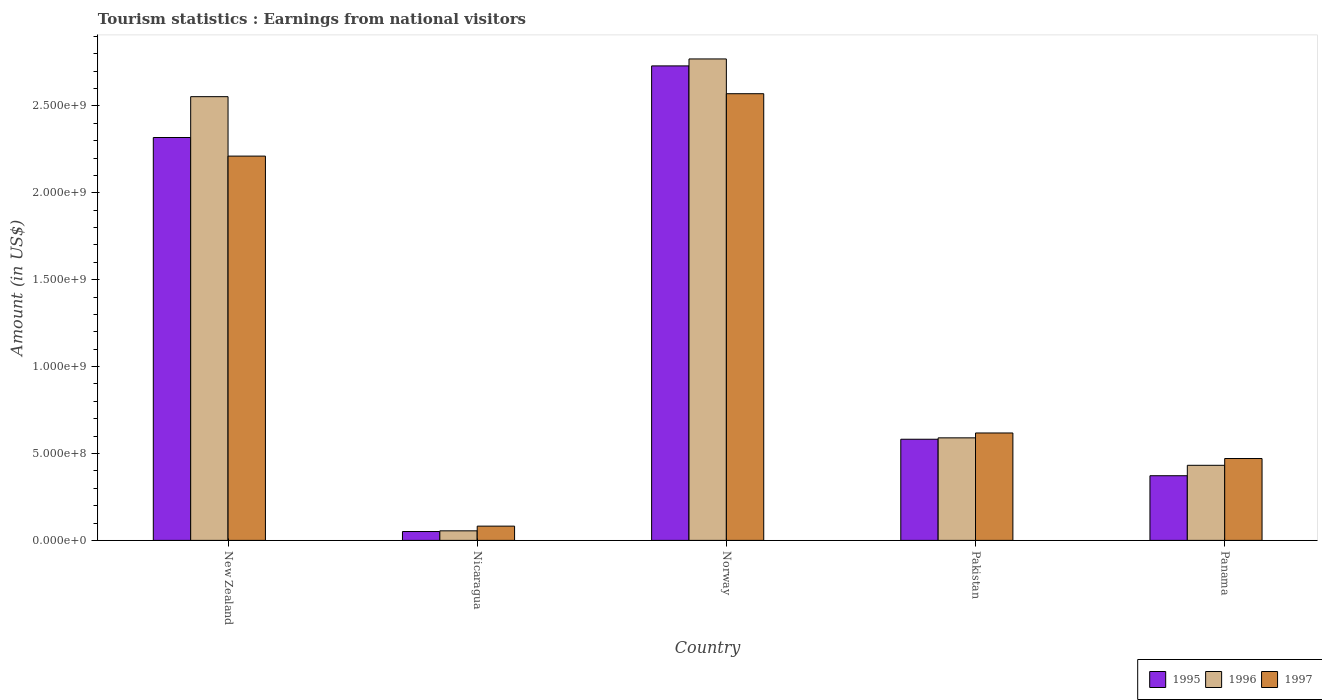How many different coloured bars are there?
Provide a short and direct response. 3. How many groups of bars are there?
Provide a short and direct response. 5. How many bars are there on the 4th tick from the right?
Your response must be concise. 3. What is the label of the 2nd group of bars from the left?
Offer a terse response. Nicaragua. In how many cases, is the number of bars for a given country not equal to the number of legend labels?
Make the answer very short. 0. What is the earnings from national visitors in 1995 in New Zealand?
Offer a terse response. 2.32e+09. Across all countries, what is the maximum earnings from national visitors in 1997?
Your answer should be compact. 2.57e+09. Across all countries, what is the minimum earnings from national visitors in 1997?
Offer a terse response. 8.20e+07. In which country was the earnings from national visitors in 1995 minimum?
Keep it short and to the point. Nicaragua. What is the total earnings from national visitors in 1996 in the graph?
Your response must be concise. 6.40e+09. What is the difference between the earnings from national visitors in 1996 in Norway and that in Pakistan?
Provide a succinct answer. 2.18e+09. What is the difference between the earnings from national visitors in 1996 in Norway and the earnings from national visitors in 1995 in Panama?
Keep it short and to the point. 2.40e+09. What is the average earnings from national visitors in 1997 per country?
Give a very brief answer. 1.19e+09. What is the difference between the earnings from national visitors of/in 1997 and earnings from national visitors of/in 1995 in New Zealand?
Give a very brief answer. -1.07e+08. In how many countries, is the earnings from national visitors in 1997 greater than 1600000000 US$?
Your answer should be very brief. 2. What is the ratio of the earnings from national visitors in 1997 in Pakistan to that in Panama?
Ensure brevity in your answer.  1.31. Is the earnings from national visitors in 1995 in Nicaragua less than that in Norway?
Give a very brief answer. Yes. Is the difference between the earnings from national visitors in 1997 in New Zealand and Pakistan greater than the difference between the earnings from national visitors in 1995 in New Zealand and Pakistan?
Offer a terse response. No. What is the difference between the highest and the second highest earnings from national visitors in 1995?
Make the answer very short. 2.15e+09. What is the difference between the highest and the lowest earnings from national visitors in 1995?
Make the answer very short. 2.68e+09. What does the 3rd bar from the left in New Zealand represents?
Give a very brief answer. 1997. What does the 1st bar from the right in Pakistan represents?
Provide a succinct answer. 1997. How many countries are there in the graph?
Make the answer very short. 5. What is the difference between two consecutive major ticks on the Y-axis?
Provide a succinct answer. 5.00e+08. Are the values on the major ticks of Y-axis written in scientific E-notation?
Make the answer very short. Yes. Does the graph contain any zero values?
Make the answer very short. No. Where does the legend appear in the graph?
Give a very brief answer. Bottom right. How are the legend labels stacked?
Your response must be concise. Horizontal. What is the title of the graph?
Give a very brief answer. Tourism statistics : Earnings from national visitors. What is the label or title of the Y-axis?
Your answer should be compact. Amount (in US$). What is the Amount (in US$) of 1995 in New Zealand?
Provide a short and direct response. 2.32e+09. What is the Amount (in US$) of 1996 in New Zealand?
Make the answer very short. 2.55e+09. What is the Amount (in US$) in 1997 in New Zealand?
Your response must be concise. 2.21e+09. What is the Amount (in US$) of 1995 in Nicaragua?
Offer a terse response. 5.10e+07. What is the Amount (in US$) of 1996 in Nicaragua?
Your answer should be compact. 5.50e+07. What is the Amount (in US$) in 1997 in Nicaragua?
Your answer should be very brief. 8.20e+07. What is the Amount (in US$) of 1995 in Norway?
Your answer should be compact. 2.73e+09. What is the Amount (in US$) of 1996 in Norway?
Keep it short and to the point. 2.77e+09. What is the Amount (in US$) of 1997 in Norway?
Offer a terse response. 2.57e+09. What is the Amount (in US$) of 1995 in Pakistan?
Your answer should be very brief. 5.82e+08. What is the Amount (in US$) of 1996 in Pakistan?
Ensure brevity in your answer.  5.90e+08. What is the Amount (in US$) in 1997 in Pakistan?
Provide a short and direct response. 6.18e+08. What is the Amount (in US$) in 1995 in Panama?
Offer a terse response. 3.72e+08. What is the Amount (in US$) in 1996 in Panama?
Your answer should be compact. 4.32e+08. What is the Amount (in US$) in 1997 in Panama?
Keep it short and to the point. 4.71e+08. Across all countries, what is the maximum Amount (in US$) in 1995?
Make the answer very short. 2.73e+09. Across all countries, what is the maximum Amount (in US$) in 1996?
Offer a very short reply. 2.77e+09. Across all countries, what is the maximum Amount (in US$) of 1997?
Make the answer very short. 2.57e+09. Across all countries, what is the minimum Amount (in US$) of 1995?
Provide a succinct answer. 5.10e+07. Across all countries, what is the minimum Amount (in US$) in 1996?
Make the answer very short. 5.50e+07. Across all countries, what is the minimum Amount (in US$) in 1997?
Keep it short and to the point. 8.20e+07. What is the total Amount (in US$) in 1995 in the graph?
Your response must be concise. 6.05e+09. What is the total Amount (in US$) of 1996 in the graph?
Give a very brief answer. 6.40e+09. What is the total Amount (in US$) in 1997 in the graph?
Provide a succinct answer. 5.95e+09. What is the difference between the Amount (in US$) in 1995 in New Zealand and that in Nicaragua?
Offer a very short reply. 2.27e+09. What is the difference between the Amount (in US$) of 1996 in New Zealand and that in Nicaragua?
Keep it short and to the point. 2.50e+09. What is the difference between the Amount (in US$) of 1997 in New Zealand and that in Nicaragua?
Ensure brevity in your answer.  2.13e+09. What is the difference between the Amount (in US$) in 1995 in New Zealand and that in Norway?
Keep it short and to the point. -4.12e+08. What is the difference between the Amount (in US$) in 1996 in New Zealand and that in Norway?
Ensure brevity in your answer.  -2.17e+08. What is the difference between the Amount (in US$) of 1997 in New Zealand and that in Norway?
Make the answer very short. -3.59e+08. What is the difference between the Amount (in US$) of 1995 in New Zealand and that in Pakistan?
Your answer should be compact. 1.74e+09. What is the difference between the Amount (in US$) in 1996 in New Zealand and that in Pakistan?
Your response must be concise. 1.96e+09. What is the difference between the Amount (in US$) in 1997 in New Zealand and that in Pakistan?
Your response must be concise. 1.59e+09. What is the difference between the Amount (in US$) of 1995 in New Zealand and that in Panama?
Ensure brevity in your answer.  1.95e+09. What is the difference between the Amount (in US$) of 1996 in New Zealand and that in Panama?
Ensure brevity in your answer.  2.12e+09. What is the difference between the Amount (in US$) in 1997 in New Zealand and that in Panama?
Make the answer very short. 1.74e+09. What is the difference between the Amount (in US$) in 1995 in Nicaragua and that in Norway?
Give a very brief answer. -2.68e+09. What is the difference between the Amount (in US$) in 1996 in Nicaragua and that in Norway?
Your answer should be very brief. -2.72e+09. What is the difference between the Amount (in US$) of 1997 in Nicaragua and that in Norway?
Give a very brief answer. -2.49e+09. What is the difference between the Amount (in US$) in 1995 in Nicaragua and that in Pakistan?
Your response must be concise. -5.31e+08. What is the difference between the Amount (in US$) in 1996 in Nicaragua and that in Pakistan?
Your answer should be very brief. -5.35e+08. What is the difference between the Amount (in US$) of 1997 in Nicaragua and that in Pakistan?
Your answer should be very brief. -5.36e+08. What is the difference between the Amount (in US$) of 1995 in Nicaragua and that in Panama?
Your answer should be compact. -3.21e+08. What is the difference between the Amount (in US$) in 1996 in Nicaragua and that in Panama?
Make the answer very short. -3.77e+08. What is the difference between the Amount (in US$) in 1997 in Nicaragua and that in Panama?
Make the answer very short. -3.89e+08. What is the difference between the Amount (in US$) of 1995 in Norway and that in Pakistan?
Give a very brief answer. 2.15e+09. What is the difference between the Amount (in US$) of 1996 in Norway and that in Pakistan?
Your answer should be compact. 2.18e+09. What is the difference between the Amount (in US$) of 1997 in Norway and that in Pakistan?
Offer a terse response. 1.95e+09. What is the difference between the Amount (in US$) in 1995 in Norway and that in Panama?
Keep it short and to the point. 2.36e+09. What is the difference between the Amount (in US$) in 1996 in Norway and that in Panama?
Offer a very short reply. 2.34e+09. What is the difference between the Amount (in US$) in 1997 in Norway and that in Panama?
Your response must be concise. 2.10e+09. What is the difference between the Amount (in US$) of 1995 in Pakistan and that in Panama?
Offer a very short reply. 2.10e+08. What is the difference between the Amount (in US$) in 1996 in Pakistan and that in Panama?
Ensure brevity in your answer.  1.58e+08. What is the difference between the Amount (in US$) of 1997 in Pakistan and that in Panama?
Your response must be concise. 1.47e+08. What is the difference between the Amount (in US$) in 1995 in New Zealand and the Amount (in US$) in 1996 in Nicaragua?
Give a very brief answer. 2.26e+09. What is the difference between the Amount (in US$) of 1995 in New Zealand and the Amount (in US$) of 1997 in Nicaragua?
Offer a terse response. 2.24e+09. What is the difference between the Amount (in US$) of 1996 in New Zealand and the Amount (in US$) of 1997 in Nicaragua?
Your response must be concise. 2.47e+09. What is the difference between the Amount (in US$) of 1995 in New Zealand and the Amount (in US$) of 1996 in Norway?
Provide a succinct answer. -4.52e+08. What is the difference between the Amount (in US$) in 1995 in New Zealand and the Amount (in US$) in 1997 in Norway?
Offer a terse response. -2.52e+08. What is the difference between the Amount (in US$) of 1996 in New Zealand and the Amount (in US$) of 1997 in Norway?
Keep it short and to the point. -1.70e+07. What is the difference between the Amount (in US$) in 1995 in New Zealand and the Amount (in US$) in 1996 in Pakistan?
Provide a succinct answer. 1.73e+09. What is the difference between the Amount (in US$) in 1995 in New Zealand and the Amount (in US$) in 1997 in Pakistan?
Provide a succinct answer. 1.70e+09. What is the difference between the Amount (in US$) of 1996 in New Zealand and the Amount (in US$) of 1997 in Pakistan?
Keep it short and to the point. 1.94e+09. What is the difference between the Amount (in US$) of 1995 in New Zealand and the Amount (in US$) of 1996 in Panama?
Your answer should be compact. 1.89e+09. What is the difference between the Amount (in US$) of 1995 in New Zealand and the Amount (in US$) of 1997 in Panama?
Your answer should be very brief. 1.85e+09. What is the difference between the Amount (in US$) of 1996 in New Zealand and the Amount (in US$) of 1997 in Panama?
Your response must be concise. 2.08e+09. What is the difference between the Amount (in US$) of 1995 in Nicaragua and the Amount (in US$) of 1996 in Norway?
Provide a succinct answer. -2.72e+09. What is the difference between the Amount (in US$) in 1995 in Nicaragua and the Amount (in US$) in 1997 in Norway?
Offer a terse response. -2.52e+09. What is the difference between the Amount (in US$) in 1996 in Nicaragua and the Amount (in US$) in 1997 in Norway?
Give a very brief answer. -2.52e+09. What is the difference between the Amount (in US$) of 1995 in Nicaragua and the Amount (in US$) of 1996 in Pakistan?
Give a very brief answer. -5.39e+08. What is the difference between the Amount (in US$) of 1995 in Nicaragua and the Amount (in US$) of 1997 in Pakistan?
Your response must be concise. -5.67e+08. What is the difference between the Amount (in US$) of 1996 in Nicaragua and the Amount (in US$) of 1997 in Pakistan?
Offer a terse response. -5.63e+08. What is the difference between the Amount (in US$) in 1995 in Nicaragua and the Amount (in US$) in 1996 in Panama?
Keep it short and to the point. -3.81e+08. What is the difference between the Amount (in US$) of 1995 in Nicaragua and the Amount (in US$) of 1997 in Panama?
Make the answer very short. -4.20e+08. What is the difference between the Amount (in US$) in 1996 in Nicaragua and the Amount (in US$) in 1997 in Panama?
Ensure brevity in your answer.  -4.16e+08. What is the difference between the Amount (in US$) of 1995 in Norway and the Amount (in US$) of 1996 in Pakistan?
Keep it short and to the point. 2.14e+09. What is the difference between the Amount (in US$) in 1995 in Norway and the Amount (in US$) in 1997 in Pakistan?
Keep it short and to the point. 2.11e+09. What is the difference between the Amount (in US$) of 1996 in Norway and the Amount (in US$) of 1997 in Pakistan?
Provide a short and direct response. 2.15e+09. What is the difference between the Amount (in US$) in 1995 in Norway and the Amount (in US$) in 1996 in Panama?
Offer a very short reply. 2.30e+09. What is the difference between the Amount (in US$) of 1995 in Norway and the Amount (in US$) of 1997 in Panama?
Give a very brief answer. 2.26e+09. What is the difference between the Amount (in US$) of 1996 in Norway and the Amount (in US$) of 1997 in Panama?
Your answer should be very brief. 2.30e+09. What is the difference between the Amount (in US$) of 1995 in Pakistan and the Amount (in US$) of 1996 in Panama?
Make the answer very short. 1.50e+08. What is the difference between the Amount (in US$) of 1995 in Pakistan and the Amount (in US$) of 1997 in Panama?
Keep it short and to the point. 1.11e+08. What is the difference between the Amount (in US$) of 1996 in Pakistan and the Amount (in US$) of 1997 in Panama?
Offer a terse response. 1.19e+08. What is the average Amount (in US$) of 1995 per country?
Your response must be concise. 1.21e+09. What is the average Amount (in US$) in 1996 per country?
Provide a succinct answer. 1.28e+09. What is the average Amount (in US$) in 1997 per country?
Your response must be concise. 1.19e+09. What is the difference between the Amount (in US$) of 1995 and Amount (in US$) of 1996 in New Zealand?
Keep it short and to the point. -2.35e+08. What is the difference between the Amount (in US$) in 1995 and Amount (in US$) in 1997 in New Zealand?
Make the answer very short. 1.07e+08. What is the difference between the Amount (in US$) of 1996 and Amount (in US$) of 1997 in New Zealand?
Your response must be concise. 3.42e+08. What is the difference between the Amount (in US$) of 1995 and Amount (in US$) of 1996 in Nicaragua?
Provide a succinct answer. -4.00e+06. What is the difference between the Amount (in US$) of 1995 and Amount (in US$) of 1997 in Nicaragua?
Your answer should be compact. -3.10e+07. What is the difference between the Amount (in US$) in 1996 and Amount (in US$) in 1997 in Nicaragua?
Provide a short and direct response. -2.70e+07. What is the difference between the Amount (in US$) in 1995 and Amount (in US$) in 1996 in Norway?
Your response must be concise. -4.00e+07. What is the difference between the Amount (in US$) in 1995 and Amount (in US$) in 1997 in Norway?
Provide a succinct answer. 1.60e+08. What is the difference between the Amount (in US$) of 1996 and Amount (in US$) of 1997 in Norway?
Provide a short and direct response. 2.00e+08. What is the difference between the Amount (in US$) in 1995 and Amount (in US$) in 1996 in Pakistan?
Your answer should be compact. -8.00e+06. What is the difference between the Amount (in US$) in 1995 and Amount (in US$) in 1997 in Pakistan?
Your answer should be compact. -3.60e+07. What is the difference between the Amount (in US$) of 1996 and Amount (in US$) of 1997 in Pakistan?
Provide a succinct answer. -2.80e+07. What is the difference between the Amount (in US$) of 1995 and Amount (in US$) of 1996 in Panama?
Provide a succinct answer. -6.00e+07. What is the difference between the Amount (in US$) in 1995 and Amount (in US$) in 1997 in Panama?
Provide a short and direct response. -9.90e+07. What is the difference between the Amount (in US$) in 1996 and Amount (in US$) in 1997 in Panama?
Keep it short and to the point. -3.90e+07. What is the ratio of the Amount (in US$) of 1995 in New Zealand to that in Nicaragua?
Provide a short and direct response. 45.45. What is the ratio of the Amount (in US$) in 1996 in New Zealand to that in Nicaragua?
Keep it short and to the point. 46.42. What is the ratio of the Amount (in US$) of 1997 in New Zealand to that in Nicaragua?
Your answer should be compact. 26.96. What is the ratio of the Amount (in US$) in 1995 in New Zealand to that in Norway?
Offer a terse response. 0.85. What is the ratio of the Amount (in US$) in 1996 in New Zealand to that in Norway?
Ensure brevity in your answer.  0.92. What is the ratio of the Amount (in US$) of 1997 in New Zealand to that in Norway?
Offer a terse response. 0.86. What is the ratio of the Amount (in US$) in 1995 in New Zealand to that in Pakistan?
Offer a very short reply. 3.98. What is the ratio of the Amount (in US$) in 1996 in New Zealand to that in Pakistan?
Provide a short and direct response. 4.33. What is the ratio of the Amount (in US$) in 1997 in New Zealand to that in Pakistan?
Give a very brief answer. 3.58. What is the ratio of the Amount (in US$) of 1995 in New Zealand to that in Panama?
Make the answer very short. 6.23. What is the ratio of the Amount (in US$) in 1996 in New Zealand to that in Panama?
Offer a terse response. 5.91. What is the ratio of the Amount (in US$) of 1997 in New Zealand to that in Panama?
Keep it short and to the point. 4.69. What is the ratio of the Amount (in US$) of 1995 in Nicaragua to that in Norway?
Offer a very short reply. 0.02. What is the ratio of the Amount (in US$) of 1996 in Nicaragua to that in Norway?
Ensure brevity in your answer.  0.02. What is the ratio of the Amount (in US$) of 1997 in Nicaragua to that in Norway?
Your answer should be compact. 0.03. What is the ratio of the Amount (in US$) of 1995 in Nicaragua to that in Pakistan?
Give a very brief answer. 0.09. What is the ratio of the Amount (in US$) of 1996 in Nicaragua to that in Pakistan?
Your answer should be compact. 0.09. What is the ratio of the Amount (in US$) of 1997 in Nicaragua to that in Pakistan?
Make the answer very short. 0.13. What is the ratio of the Amount (in US$) in 1995 in Nicaragua to that in Panama?
Ensure brevity in your answer.  0.14. What is the ratio of the Amount (in US$) in 1996 in Nicaragua to that in Panama?
Make the answer very short. 0.13. What is the ratio of the Amount (in US$) of 1997 in Nicaragua to that in Panama?
Ensure brevity in your answer.  0.17. What is the ratio of the Amount (in US$) in 1995 in Norway to that in Pakistan?
Your response must be concise. 4.69. What is the ratio of the Amount (in US$) in 1996 in Norway to that in Pakistan?
Ensure brevity in your answer.  4.69. What is the ratio of the Amount (in US$) of 1997 in Norway to that in Pakistan?
Make the answer very short. 4.16. What is the ratio of the Amount (in US$) of 1995 in Norway to that in Panama?
Offer a terse response. 7.34. What is the ratio of the Amount (in US$) in 1996 in Norway to that in Panama?
Your response must be concise. 6.41. What is the ratio of the Amount (in US$) in 1997 in Norway to that in Panama?
Give a very brief answer. 5.46. What is the ratio of the Amount (in US$) in 1995 in Pakistan to that in Panama?
Give a very brief answer. 1.56. What is the ratio of the Amount (in US$) in 1996 in Pakistan to that in Panama?
Make the answer very short. 1.37. What is the ratio of the Amount (in US$) of 1997 in Pakistan to that in Panama?
Offer a very short reply. 1.31. What is the difference between the highest and the second highest Amount (in US$) of 1995?
Provide a succinct answer. 4.12e+08. What is the difference between the highest and the second highest Amount (in US$) of 1996?
Provide a succinct answer. 2.17e+08. What is the difference between the highest and the second highest Amount (in US$) of 1997?
Provide a short and direct response. 3.59e+08. What is the difference between the highest and the lowest Amount (in US$) of 1995?
Your response must be concise. 2.68e+09. What is the difference between the highest and the lowest Amount (in US$) of 1996?
Give a very brief answer. 2.72e+09. What is the difference between the highest and the lowest Amount (in US$) in 1997?
Ensure brevity in your answer.  2.49e+09. 